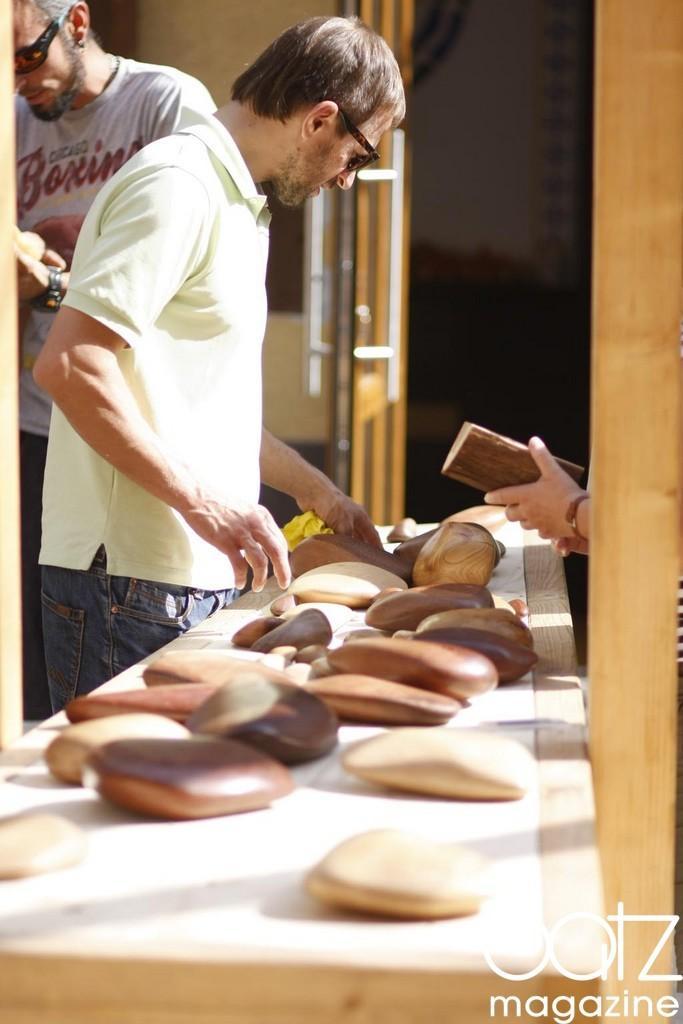Describe this image in one or two sentences. In this picture we can see two men standing here, there is a table here, we can see some stones on the table, these two persons wore goggles, at the right bottom there is some text. 